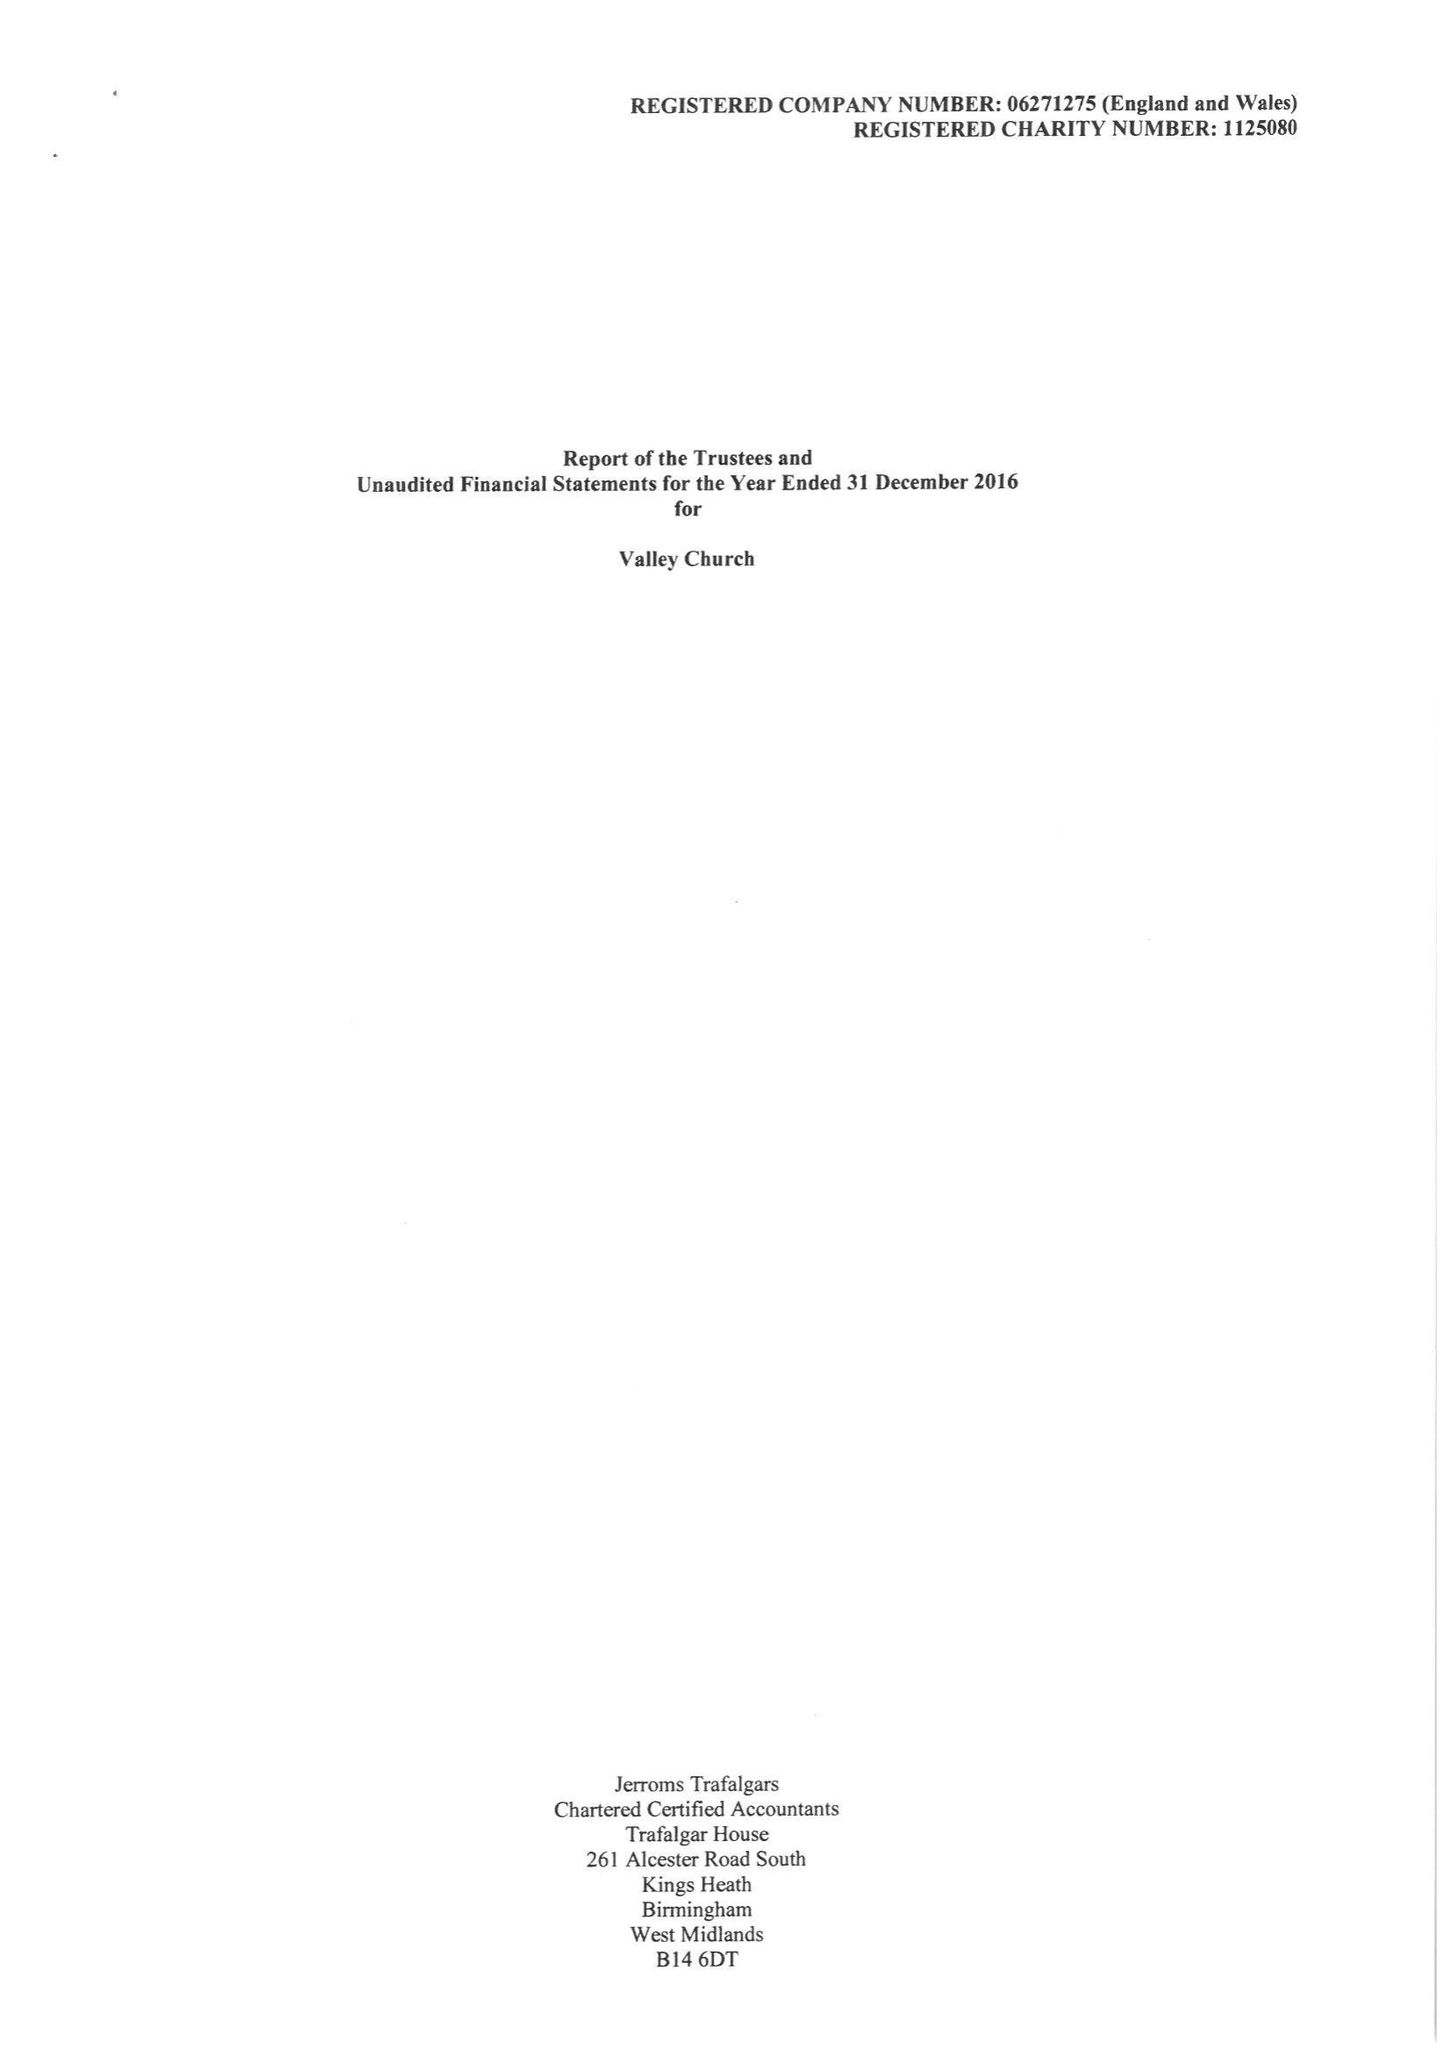What is the value for the income_annually_in_british_pounds?
Answer the question using a single word or phrase. 245380.00 